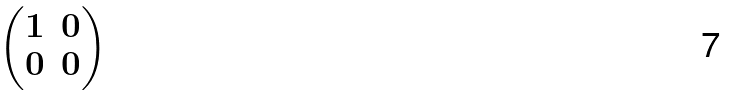<formula> <loc_0><loc_0><loc_500><loc_500>\begin{pmatrix} 1 & 0 \\ 0 & 0 \\ \end{pmatrix}</formula> 